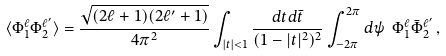Convert formula to latex. <formula><loc_0><loc_0><loc_500><loc_500>\langle \Phi _ { 1 } ^ { \ell } \Phi _ { 2 } ^ { \ell ^ { \prime } } \rangle = \frac { \sqrt { ( 2 \ell + 1 ) ( 2 \ell ^ { \prime } + 1 ) } } { 4 \pi ^ { 2 } } \int _ { | t | < 1 } \frac { d t d \bar { t } } { ( 1 - | t | ^ { 2 } ) ^ { 2 } } \int _ { - 2 \pi } ^ { 2 \pi } d \psi \ \Phi _ { 1 } ^ { \ell } \bar { \Phi } _ { 2 } ^ { \ell ^ { \prime } } \, ,</formula> 